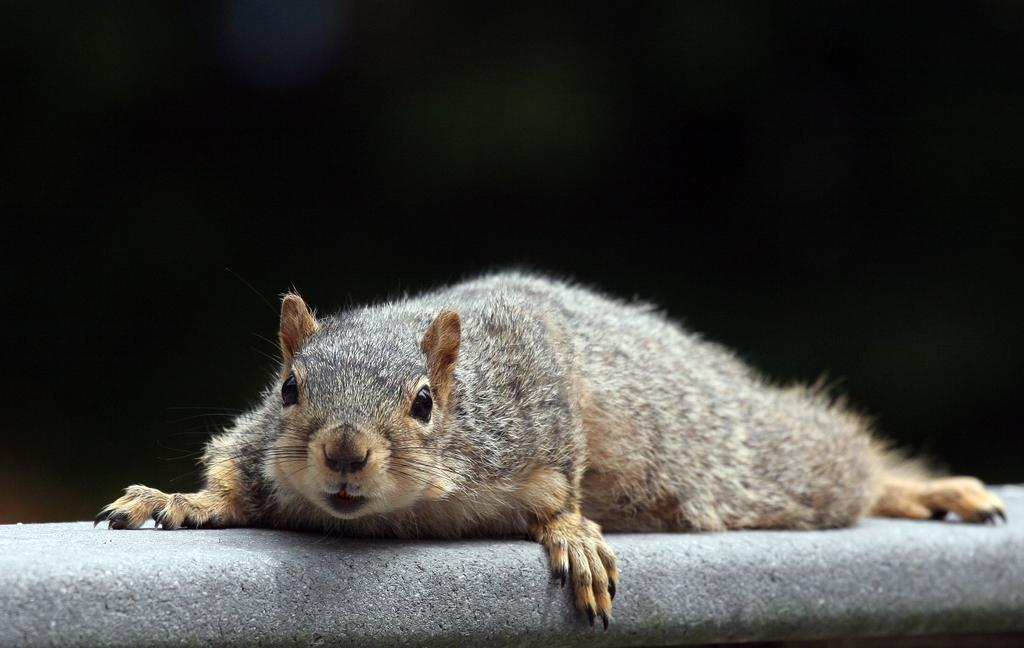What type of creature is present in the image? There is an animal in the image. How is the animal positioned in the image? The animal is laid on the floor. What color is the background of the image? The background of the image is black. What type of toothbrush is the animal using in the image? There is no toothbrush present in the image, and the animal is not using any such object. 